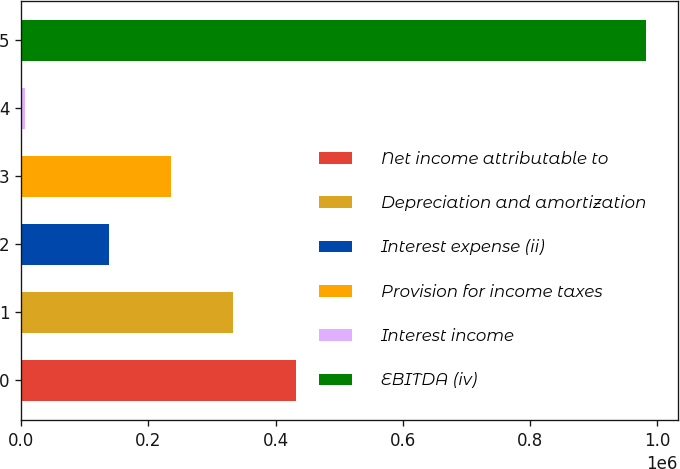<chart> <loc_0><loc_0><loc_500><loc_500><bar_chart><fcel>Net income attributable to<fcel>Depreciation and amortization<fcel>Interest expense (ii)<fcel>Provision for income taxes<fcel>Interest income<fcel>EBITDA (iv)<nl><fcel>431357<fcel>333698<fcel>138379<fcel>236038<fcel>6289<fcel>982883<nl></chart> 